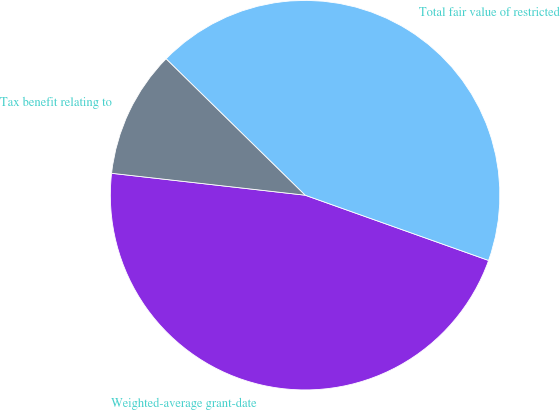Convert chart. <chart><loc_0><loc_0><loc_500><loc_500><pie_chart><fcel>Weighted-average grant-date<fcel>Total fair value of restricted<fcel>Tax benefit relating to<nl><fcel>46.35%<fcel>43.09%<fcel>10.55%<nl></chart> 